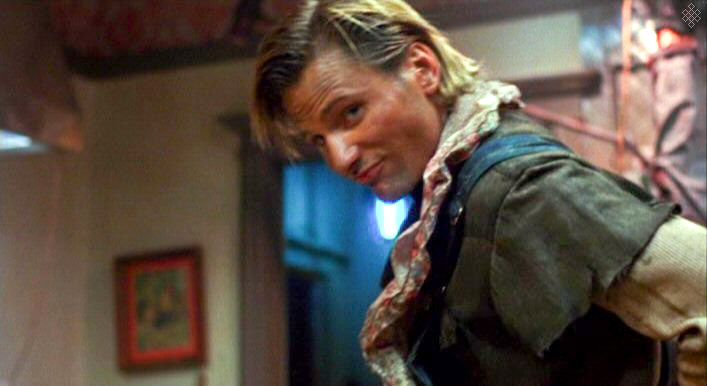What might be the function of the room shown in the background? The room in the background, with its wooden beam and vintage details like the framed painting, suggests a personal or casual space, possibly a study or a living area in a rustic setting. The overall ambiance is warm and inviting, indicating a space used for relaxation or informal gatherings. 